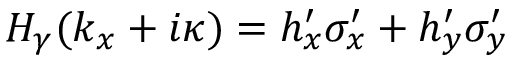<formula> <loc_0><loc_0><loc_500><loc_500>\begin{array} { r } { H _ { \gamma } ( k _ { x } + i \kappa ) = h _ { x } ^ { \prime } \sigma _ { x } ^ { \prime } + h _ { y } ^ { \prime } \sigma _ { y } ^ { \prime } } \end{array}</formula> 